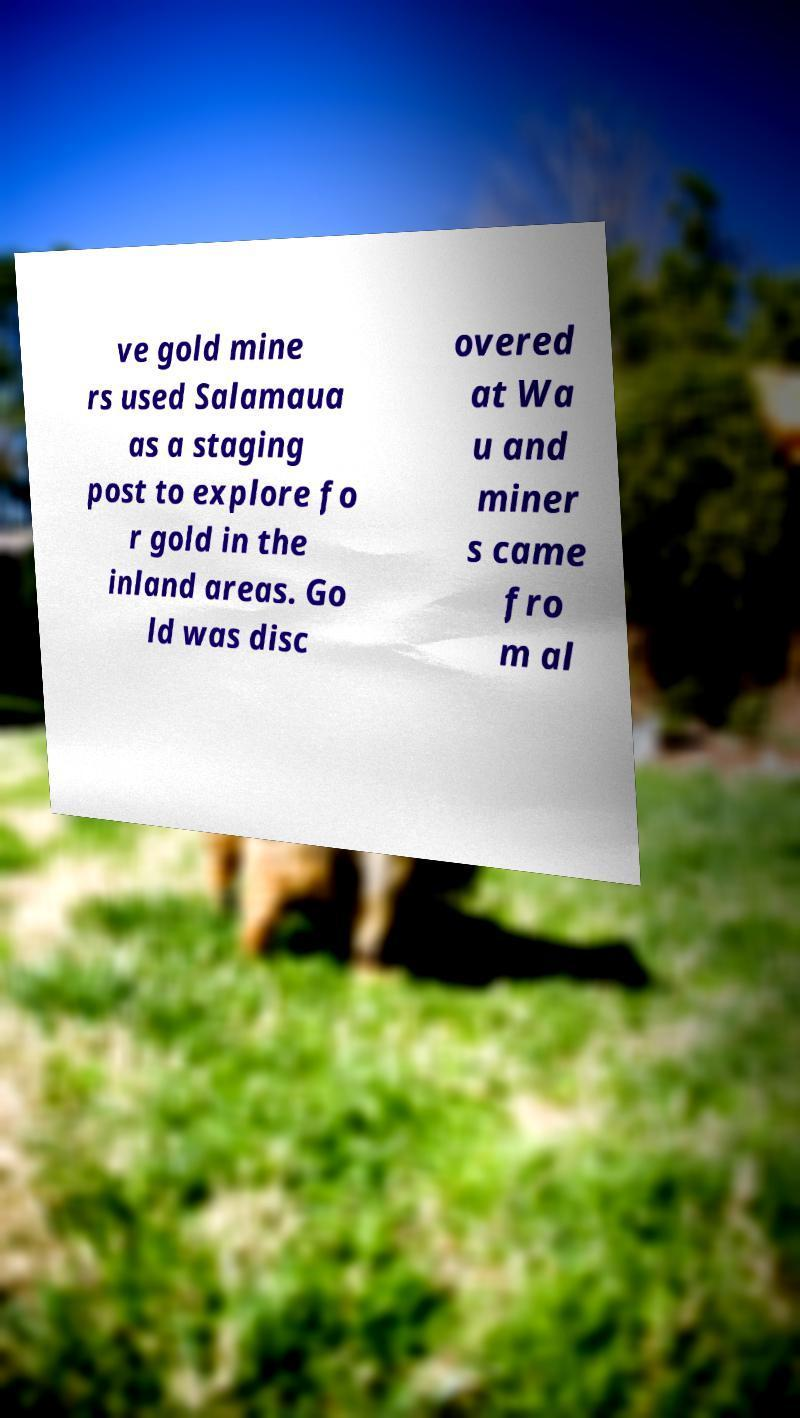Please read and relay the text visible in this image. What does it say? ve gold mine rs used Salamaua as a staging post to explore fo r gold in the inland areas. Go ld was disc overed at Wa u and miner s came fro m al 